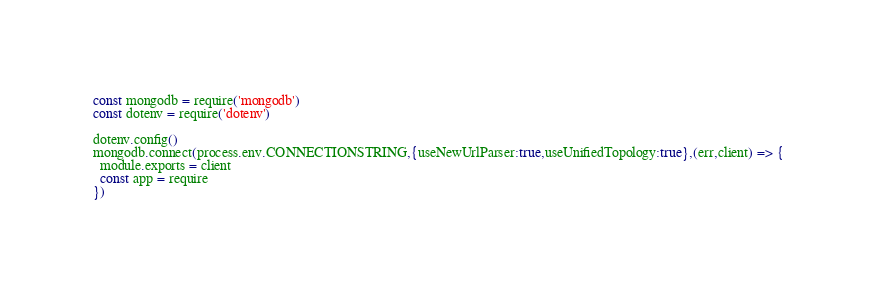Convert code to text. <code><loc_0><loc_0><loc_500><loc_500><_JavaScript_>const mongodb = require('mongodb')
const dotenv = require('dotenv')

dotenv.config()
mongodb.connect(process.env.CONNECTIONSTRING,{useNewUrlParser:true,useUnifiedTopology:true},(err,client) => {
  module.exports = client
  const app = require
})
</code> 